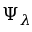Convert formula to latex. <formula><loc_0><loc_0><loc_500><loc_500>\Psi _ { \lambda }</formula> 